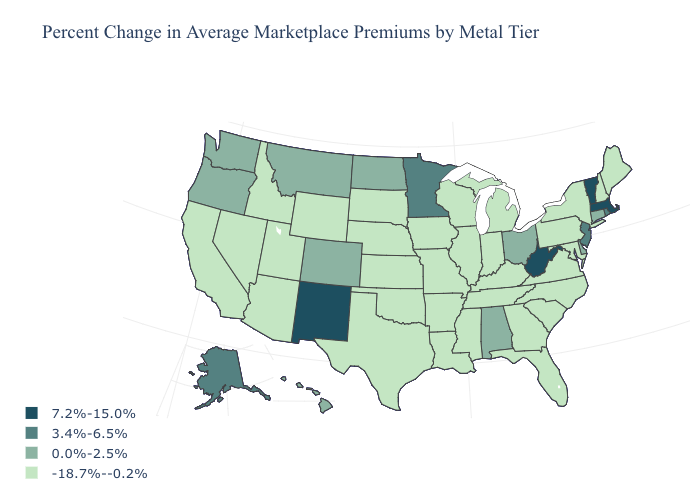What is the value of Texas?
Keep it brief. -18.7%--0.2%. Which states have the highest value in the USA?
Write a very short answer. Massachusetts, New Mexico, Vermont, West Virginia. Name the states that have a value in the range 7.2%-15.0%?
Give a very brief answer. Massachusetts, New Mexico, Vermont, West Virginia. Does California have a higher value than Arizona?
Short answer required. No. Does the first symbol in the legend represent the smallest category?
Be succinct. No. Name the states that have a value in the range -18.7%--0.2%?
Keep it brief. Arizona, Arkansas, California, Florida, Georgia, Idaho, Illinois, Indiana, Iowa, Kansas, Kentucky, Louisiana, Maine, Maryland, Michigan, Mississippi, Missouri, Nebraska, Nevada, New Hampshire, New York, North Carolina, Oklahoma, Pennsylvania, South Carolina, South Dakota, Tennessee, Texas, Utah, Virginia, Wisconsin, Wyoming. Which states have the highest value in the USA?
Write a very short answer. Massachusetts, New Mexico, Vermont, West Virginia. What is the value of Colorado?
Keep it brief. 0.0%-2.5%. What is the highest value in states that border Texas?
Keep it brief. 7.2%-15.0%. Which states hav the highest value in the Northeast?
Write a very short answer. Massachusetts, Vermont. Does Maine have the highest value in the USA?
Short answer required. No. What is the value of Maryland?
Keep it brief. -18.7%--0.2%. Which states have the highest value in the USA?
Short answer required. Massachusetts, New Mexico, Vermont, West Virginia. Which states have the highest value in the USA?
Quick response, please. Massachusetts, New Mexico, Vermont, West Virginia. What is the value of Idaho?
Keep it brief. -18.7%--0.2%. 